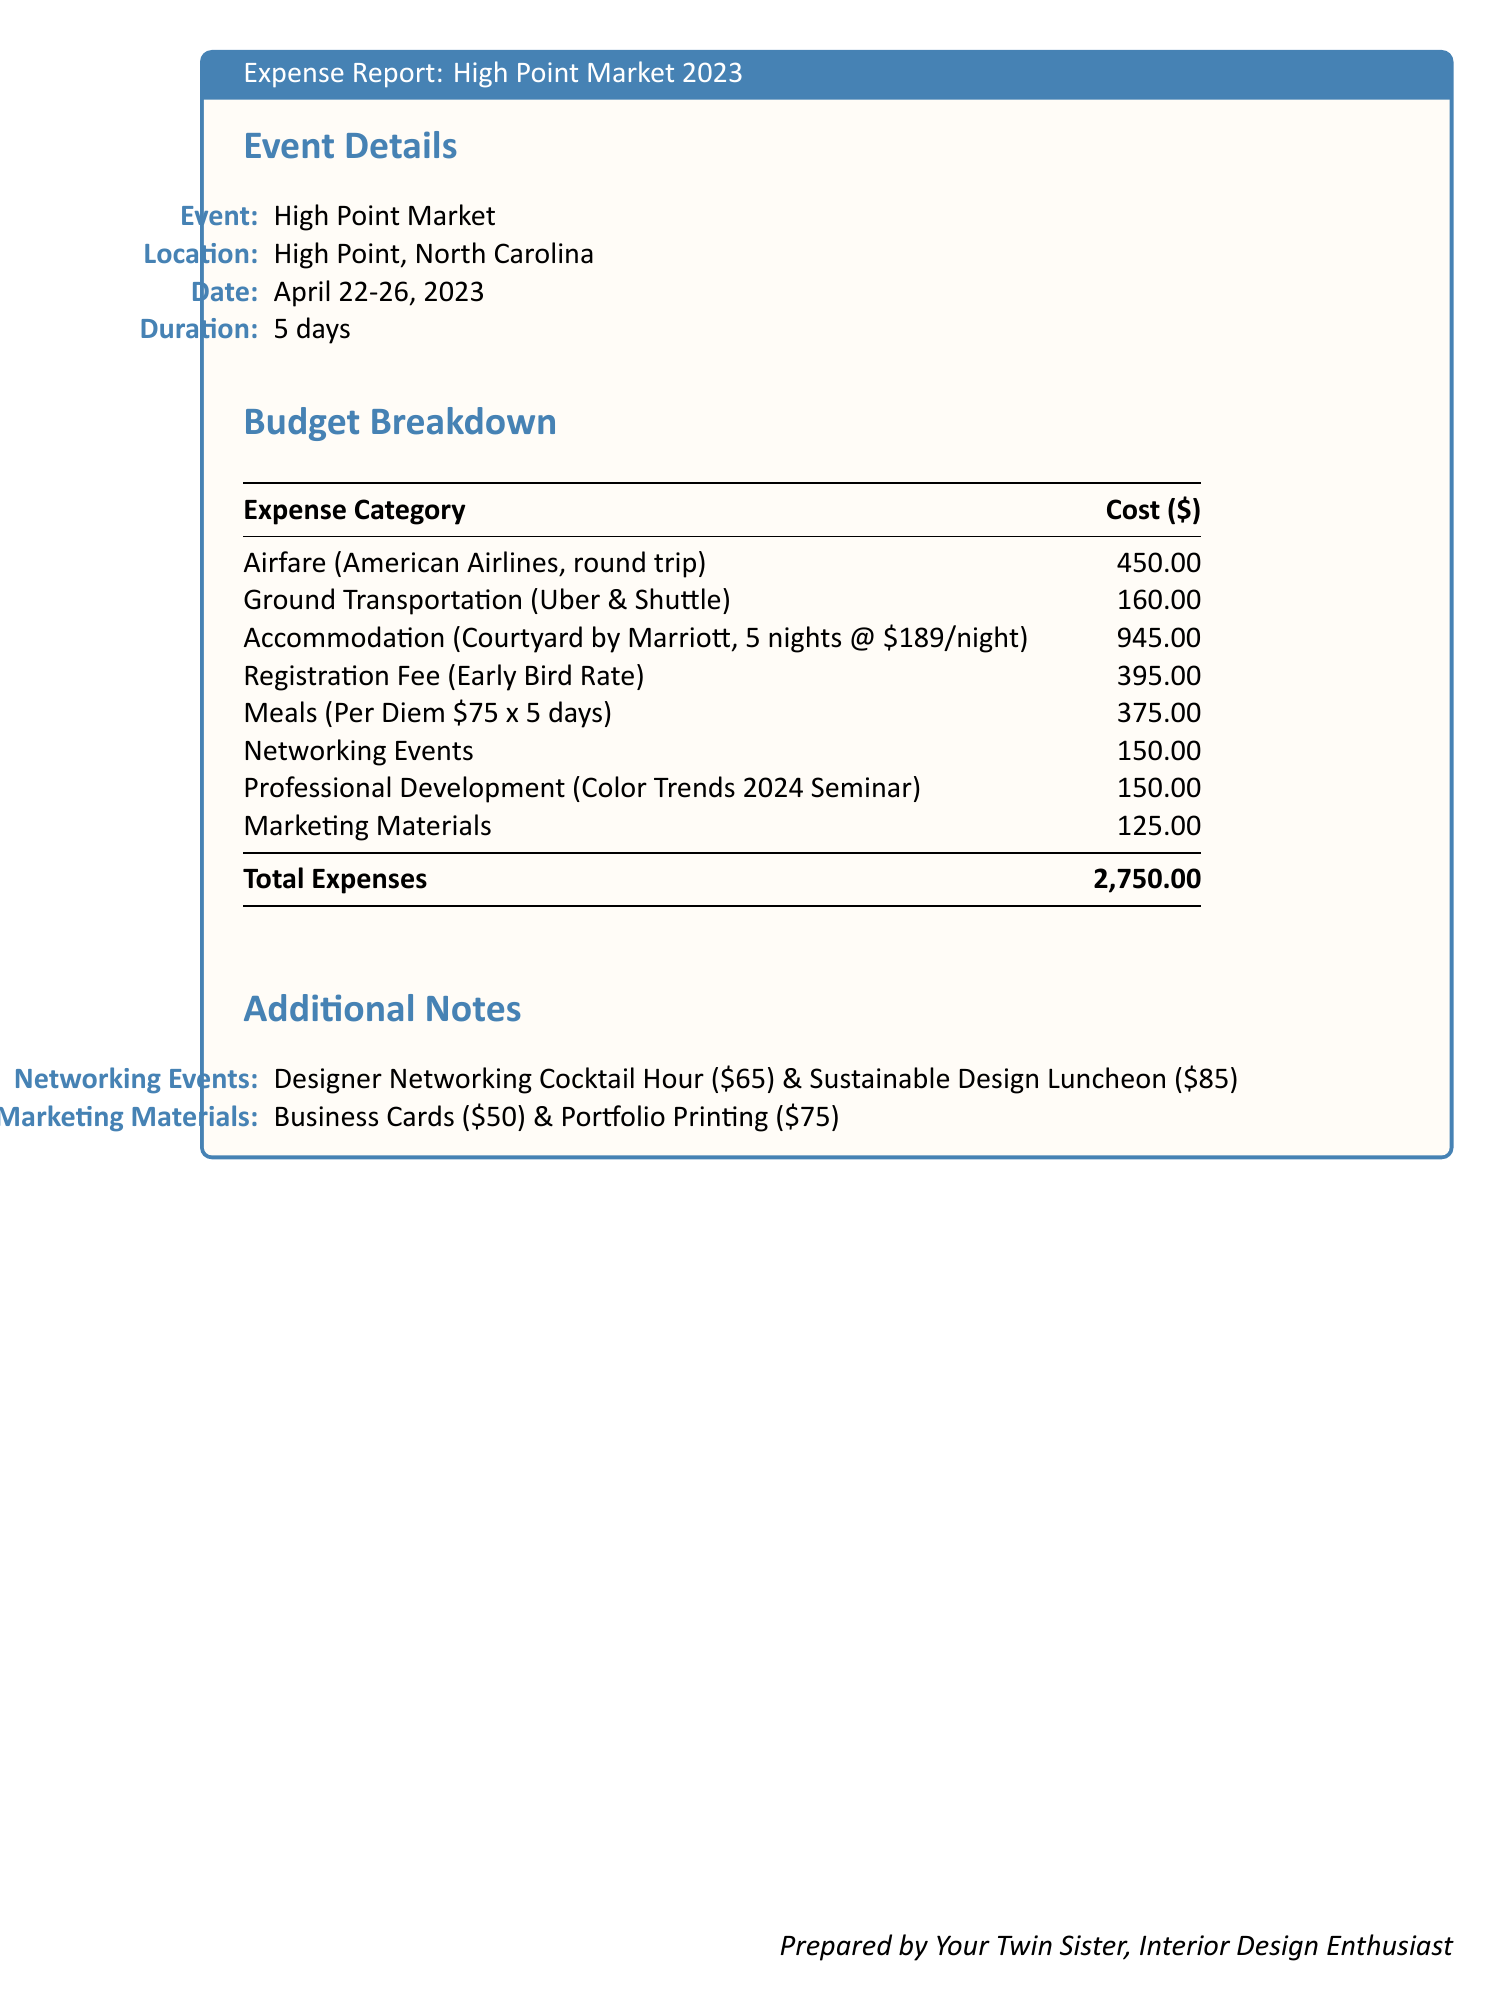what is the total cost of airfare? The airfare cost for the round trip is listed in the budget as $450.00.
Answer: $450.00 how many nights was accommodation booked? The accommodation was booked for 5 nights at the Courtyard by Marriott.
Answer: 5 nights what is the registration fee for the event? The early bird registration fee for attending the event is specified as $395.00.
Answer: $395.00 what are the two networking events mentioned? The document lists two networking events: Designer Networking Cocktail Hour and Sustainable Design Luncheon.
Answer: Designer Networking Cocktail Hour, Sustainable Design Luncheon how much was spent on meals? The meals cost is calculated at a per diem of $75 for each of the 5 days, totaling $375.00.
Answer: $375.00 what is the total expense reported? The total expenses calculated for attending the event amounts to $2,750.00.
Answer: $2,750.00 how much was allocated for professional development? The budget specifies a cost of $150.00 for the Color Trends 2024 Seminar under professional development.
Answer: $150.00 what type of document is this? This document is a detailed expense report specific to attending the High Point Market trade show.
Answer: Expense Report 